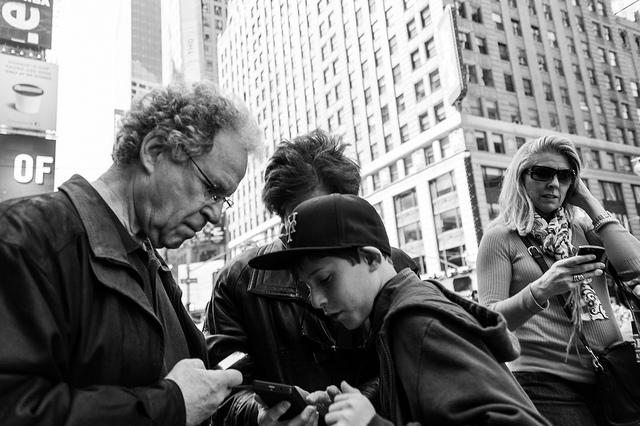Identify the text displayed in this image. OF e 